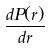<formula> <loc_0><loc_0><loc_500><loc_500>\frac { d P ( r ) } { d r }</formula> 